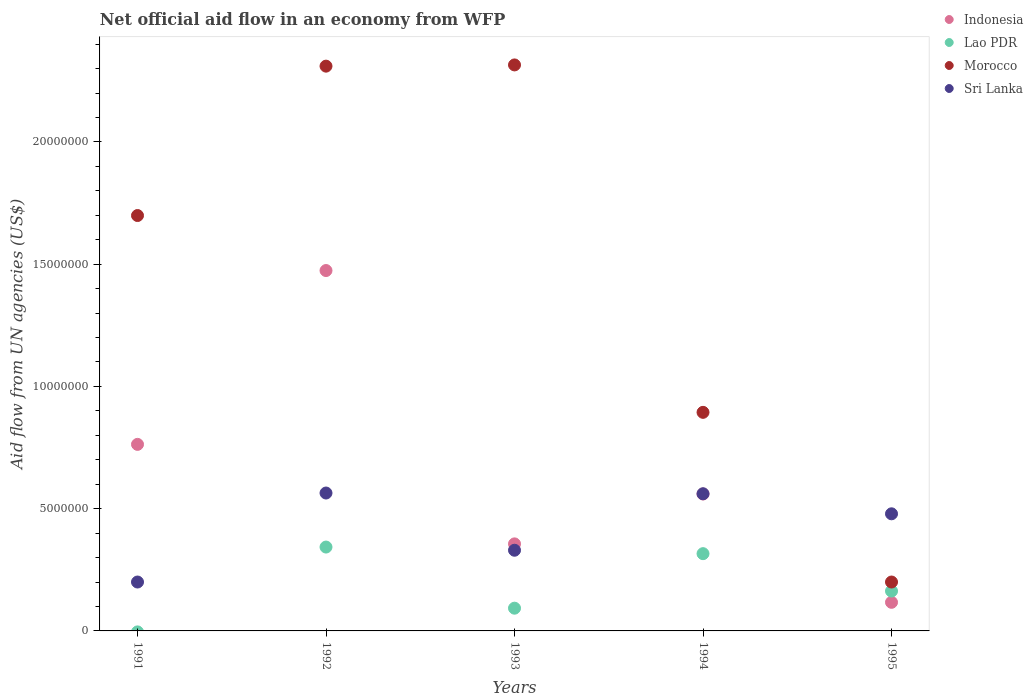Is the number of dotlines equal to the number of legend labels?
Offer a terse response. No. What is the net official aid flow in Lao PDR in 1992?
Ensure brevity in your answer.  3.43e+06. Across all years, what is the maximum net official aid flow in Morocco?
Your answer should be very brief. 2.32e+07. Across all years, what is the minimum net official aid flow in Indonesia?
Your answer should be compact. 1.17e+06. In which year was the net official aid flow in Morocco maximum?
Give a very brief answer. 1993. What is the total net official aid flow in Lao PDR in the graph?
Your answer should be very brief. 9.15e+06. What is the difference between the net official aid flow in Indonesia in 1994 and that in 1995?
Your answer should be compact. 4.43e+06. What is the difference between the net official aid flow in Morocco in 1991 and the net official aid flow in Lao PDR in 1992?
Ensure brevity in your answer.  1.36e+07. What is the average net official aid flow in Morocco per year?
Your answer should be very brief. 1.48e+07. In the year 1993, what is the difference between the net official aid flow in Morocco and net official aid flow in Lao PDR?
Keep it short and to the point. 2.22e+07. In how many years, is the net official aid flow in Lao PDR greater than 7000000 US$?
Provide a succinct answer. 0. What is the ratio of the net official aid flow in Morocco in 1991 to that in 1994?
Ensure brevity in your answer.  1.9. Is the difference between the net official aid flow in Morocco in 1992 and 1994 greater than the difference between the net official aid flow in Lao PDR in 1992 and 1994?
Your response must be concise. Yes. What is the difference between the highest and the lowest net official aid flow in Lao PDR?
Your response must be concise. 3.43e+06. Is the sum of the net official aid flow in Morocco in 1994 and 1995 greater than the maximum net official aid flow in Sri Lanka across all years?
Offer a terse response. Yes. Is it the case that in every year, the sum of the net official aid flow in Sri Lanka and net official aid flow in Morocco  is greater than the sum of net official aid flow in Lao PDR and net official aid flow in Indonesia?
Provide a succinct answer. Yes. Does the net official aid flow in Sri Lanka monotonically increase over the years?
Your answer should be compact. No. Is the net official aid flow in Morocco strictly less than the net official aid flow in Indonesia over the years?
Provide a succinct answer. No. What is the difference between two consecutive major ticks on the Y-axis?
Provide a short and direct response. 5.00e+06. Does the graph contain grids?
Your response must be concise. No. Where does the legend appear in the graph?
Give a very brief answer. Top right. What is the title of the graph?
Your response must be concise. Net official aid flow in an economy from WFP. What is the label or title of the X-axis?
Provide a short and direct response. Years. What is the label or title of the Y-axis?
Keep it short and to the point. Aid flow from UN agencies (US$). What is the Aid flow from UN agencies (US$) of Indonesia in 1991?
Provide a succinct answer. 7.63e+06. What is the Aid flow from UN agencies (US$) in Lao PDR in 1991?
Provide a short and direct response. 0. What is the Aid flow from UN agencies (US$) in Morocco in 1991?
Give a very brief answer. 1.70e+07. What is the Aid flow from UN agencies (US$) in Sri Lanka in 1991?
Offer a very short reply. 2.00e+06. What is the Aid flow from UN agencies (US$) in Indonesia in 1992?
Your response must be concise. 1.47e+07. What is the Aid flow from UN agencies (US$) of Lao PDR in 1992?
Your answer should be very brief. 3.43e+06. What is the Aid flow from UN agencies (US$) of Morocco in 1992?
Your answer should be very brief. 2.31e+07. What is the Aid flow from UN agencies (US$) of Sri Lanka in 1992?
Offer a very short reply. 5.64e+06. What is the Aid flow from UN agencies (US$) of Indonesia in 1993?
Ensure brevity in your answer.  3.56e+06. What is the Aid flow from UN agencies (US$) of Lao PDR in 1993?
Provide a short and direct response. 9.30e+05. What is the Aid flow from UN agencies (US$) in Morocco in 1993?
Give a very brief answer. 2.32e+07. What is the Aid flow from UN agencies (US$) of Sri Lanka in 1993?
Provide a short and direct response. 3.30e+06. What is the Aid flow from UN agencies (US$) of Indonesia in 1994?
Make the answer very short. 5.60e+06. What is the Aid flow from UN agencies (US$) in Lao PDR in 1994?
Provide a succinct answer. 3.16e+06. What is the Aid flow from UN agencies (US$) of Morocco in 1994?
Keep it short and to the point. 8.94e+06. What is the Aid flow from UN agencies (US$) of Sri Lanka in 1994?
Provide a succinct answer. 5.61e+06. What is the Aid flow from UN agencies (US$) of Indonesia in 1995?
Your answer should be compact. 1.17e+06. What is the Aid flow from UN agencies (US$) in Lao PDR in 1995?
Ensure brevity in your answer.  1.63e+06. What is the Aid flow from UN agencies (US$) of Sri Lanka in 1995?
Keep it short and to the point. 4.79e+06. Across all years, what is the maximum Aid flow from UN agencies (US$) in Indonesia?
Offer a terse response. 1.47e+07. Across all years, what is the maximum Aid flow from UN agencies (US$) of Lao PDR?
Keep it short and to the point. 3.43e+06. Across all years, what is the maximum Aid flow from UN agencies (US$) of Morocco?
Your answer should be very brief. 2.32e+07. Across all years, what is the maximum Aid flow from UN agencies (US$) in Sri Lanka?
Ensure brevity in your answer.  5.64e+06. Across all years, what is the minimum Aid flow from UN agencies (US$) of Indonesia?
Your response must be concise. 1.17e+06. What is the total Aid flow from UN agencies (US$) in Indonesia in the graph?
Offer a very short reply. 3.27e+07. What is the total Aid flow from UN agencies (US$) in Lao PDR in the graph?
Provide a succinct answer. 9.15e+06. What is the total Aid flow from UN agencies (US$) of Morocco in the graph?
Your answer should be compact. 7.42e+07. What is the total Aid flow from UN agencies (US$) of Sri Lanka in the graph?
Provide a short and direct response. 2.13e+07. What is the difference between the Aid flow from UN agencies (US$) of Indonesia in 1991 and that in 1992?
Give a very brief answer. -7.11e+06. What is the difference between the Aid flow from UN agencies (US$) of Morocco in 1991 and that in 1992?
Ensure brevity in your answer.  -6.11e+06. What is the difference between the Aid flow from UN agencies (US$) in Sri Lanka in 1991 and that in 1992?
Keep it short and to the point. -3.64e+06. What is the difference between the Aid flow from UN agencies (US$) of Indonesia in 1991 and that in 1993?
Keep it short and to the point. 4.07e+06. What is the difference between the Aid flow from UN agencies (US$) of Morocco in 1991 and that in 1993?
Your answer should be compact. -6.16e+06. What is the difference between the Aid flow from UN agencies (US$) in Sri Lanka in 1991 and that in 1993?
Offer a terse response. -1.30e+06. What is the difference between the Aid flow from UN agencies (US$) in Indonesia in 1991 and that in 1994?
Your response must be concise. 2.03e+06. What is the difference between the Aid flow from UN agencies (US$) in Morocco in 1991 and that in 1994?
Provide a short and direct response. 8.05e+06. What is the difference between the Aid flow from UN agencies (US$) of Sri Lanka in 1991 and that in 1994?
Provide a short and direct response. -3.61e+06. What is the difference between the Aid flow from UN agencies (US$) in Indonesia in 1991 and that in 1995?
Your answer should be compact. 6.46e+06. What is the difference between the Aid flow from UN agencies (US$) in Morocco in 1991 and that in 1995?
Offer a very short reply. 1.50e+07. What is the difference between the Aid flow from UN agencies (US$) of Sri Lanka in 1991 and that in 1995?
Your response must be concise. -2.79e+06. What is the difference between the Aid flow from UN agencies (US$) in Indonesia in 1992 and that in 1993?
Your answer should be compact. 1.12e+07. What is the difference between the Aid flow from UN agencies (US$) of Lao PDR in 1992 and that in 1993?
Keep it short and to the point. 2.50e+06. What is the difference between the Aid flow from UN agencies (US$) of Sri Lanka in 1992 and that in 1993?
Give a very brief answer. 2.34e+06. What is the difference between the Aid flow from UN agencies (US$) of Indonesia in 1992 and that in 1994?
Your answer should be very brief. 9.14e+06. What is the difference between the Aid flow from UN agencies (US$) in Morocco in 1992 and that in 1994?
Your answer should be compact. 1.42e+07. What is the difference between the Aid flow from UN agencies (US$) in Indonesia in 1992 and that in 1995?
Provide a succinct answer. 1.36e+07. What is the difference between the Aid flow from UN agencies (US$) of Lao PDR in 1992 and that in 1995?
Offer a very short reply. 1.80e+06. What is the difference between the Aid flow from UN agencies (US$) in Morocco in 1992 and that in 1995?
Give a very brief answer. 2.11e+07. What is the difference between the Aid flow from UN agencies (US$) of Sri Lanka in 1992 and that in 1995?
Offer a very short reply. 8.50e+05. What is the difference between the Aid flow from UN agencies (US$) in Indonesia in 1993 and that in 1994?
Provide a succinct answer. -2.04e+06. What is the difference between the Aid flow from UN agencies (US$) of Lao PDR in 1993 and that in 1994?
Offer a very short reply. -2.23e+06. What is the difference between the Aid flow from UN agencies (US$) of Morocco in 1993 and that in 1994?
Make the answer very short. 1.42e+07. What is the difference between the Aid flow from UN agencies (US$) of Sri Lanka in 1993 and that in 1994?
Your answer should be very brief. -2.31e+06. What is the difference between the Aid flow from UN agencies (US$) of Indonesia in 1993 and that in 1995?
Your answer should be compact. 2.39e+06. What is the difference between the Aid flow from UN agencies (US$) of Lao PDR in 1993 and that in 1995?
Offer a terse response. -7.00e+05. What is the difference between the Aid flow from UN agencies (US$) in Morocco in 1993 and that in 1995?
Provide a short and direct response. 2.12e+07. What is the difference between the Aid flow from UN agencies (US$) of Sri Lanka in 1993 and that in 1995?
Keep it short and to the point. -1.49e+06. What is the difference between the Aid flow from UN agencies (US$) of Indonesia in 1994 and that in 1995?
Your answer should be compact. 4.43e+06. What is the difference between the Aid flow from UN agencies (US$) of Lao PDR in 1994 and that in 1995?
Offer a very short reply. 1.53e+06. What is the difference between the Aid flow from UN agencies (US$) of Morocco in 1994 and that in 1995?
Your response must be concise. 6.94e+06. What is the difference between the Aid flow from UN agencies (US$) in Sri Lanka in 1994 and that in 1995?
Offer a terse response. 8.20e+05. What is the difference between the Aid flow from UN agencies (US$) in Indonesia in 1991 and the Aid flow from UN agencies (US$) in Lao PDR in 1992?
Your response must be concise. 4.20e+06. What is the difference between the Aid flow from UN agencies (US$) in Indonesia in 1991 and the Aid flow from UN agencies (US$) in Morocco in 1992?
Give a very brief answer. -1.55e+07. What is the difference between the Aid flow from UN agencies (US$) of Indonesia in 1991 and the Aid flow from UN agencies (US$) of Sri Lanka in 1992?
Ensure brevity in your answer.  1.99e+06. What is the difference between the Aid flow from UN agencies (US$) in Morocco in 1991 and the Aid flow from UN agencies (US$) in Sri Lanka in 1992?
Provide a succinct answer. 1.14e+07. What is the difference between the Aid flow from UN agencies (US$) in Indonesia in 1991 and the Aid flow from UN agencies (US$) in Lao PDR in 1993?
Your answer should be very brief. 6.70e+06. What is the difference between the Aid flow from UN agencies (US$) of Indonesia in 1991 and the Aid flow from UN agencies (US$) of Morocco in 1993?
Keep it short and to the point. -1.55e+07. What is the difference between the Aid flow from UN agencies (US$) in Indonesia in 1991 and the Aid flow from UN agencies (US$) in Sri Lanka in 1993?
Provide a short and direct response. 4.33e+06. What is the difference between the Aid flow from UN agencies (US$) in Morocco in 1991 and the Aid flow from UN agencies (US$) in Sri Lanka in 1993?
Make the answer very short. 1.37e+07. What is the difference between the Aid flow from UN agencies (US$) of Indonesia in 1991 and the Aid flow from UN agencies (US$) of Lao PDR in 1994?
Provide a short and direct response. 4.47e+06. What is the difference between the Aid flow from UN agencies (US$) of Indonesia in 1991 and the Aid flow from UN agencies (US$) of Morocco in 1994?
Make the answer very short. -1.31e+06. What is the difference between the Aid flow from UN agencies (US$) of Indonesia in 1991 and the Aid flow from UN agencies (US$) of Sri Lanka in 1994?
Give a very brief answer. 2.02e+06. What is the difference between the Aid flow from UN agencies (US$) in Morocco in 1991 and the Aid flow from UN agencies (US$) in Sri Lanka in 1994?
Offer a very short reply. 1.14e+07. What is the difference between the Aid flow from UN agencies (US$) of Indonesia in 1991 and the Aid flow from UN agencies (US$) of Morocco in 1995?
Keep it short and to the point. 5.63e+06. What is the difference between the Aid flow from UN agencies (US$) of Indonesia in 1991 and the Aid flow from UN agencies (US$) of Sri Lanka in 1995?
Ensure brevity in your answer.  2.84e+06. What is the difference between the Aid flow from UN agencies (US$) of Morocco in 1991 and the Aid flow from UN agencies (US$) of Sri Lanka in 1995?
Provide a succinct answer. 1.22e+07. What is the difference between the Aid flow from UN agencies (US$) of Indonesia in 1992 and the Aid flow from UN agencies (US$) of Lao PDR in 1993?
Provide a short and direct response. 1.38e+07. What is the difference between the Aid flow from UN agencies (US$) of Indonesia in 1992 and the Aid flow from UN agencies (US$) of Morocco in 1993?
Your response must be concise. -8.41e+06. What is the difference between the Aid flow from UN agencies (US$) of Indonesia in 1992 and the Aid flow from UN agencies (US$) of Sri Lanka in 1993?
Keep it short and to the point. 1.14e+07. What is the difference between the Aid flow from UN agencies (US$) in Lao PDR in 1992 and the Aid flow from UN agencies (US$) in Morocco in 1993?
Provide a succinct answer. -1.97e+07. What is the difference between the Aid flow from UN agencies (US$) in Morocco in 1992 and the Aid flow from UN agencies (US$) in Sri Lanka in 1993?
Ensure brevity in your answer.  1.98e+07. What is the difference between the Aid flow from UN agencies (US$) of Indonesia in 1992 and the Aid flow from UN agencies (US$) of Lao PDR in 1994?
Your response must be concise. 1.16e+07. What is the difference between the Aid flow from UN agencies (US$) of Indonesia in 1992 and the Aid flow from UN agencies (US$) of Morocco in 1994?
Your response must be concise. 5.80e+06. What is the difference between the Aid flow from UN agencies (US$) in Indonesia in 1992 and the Aid flow from UN agencies (US$) in Sri Lanka in 1994?
Provide a succinct answer. 9.13e+06. What is the difference between the Aid flow from UN agencies (US$) in Lao PDR in 1992 and the Aid flow from UN agencies (US$) in Morocco in 1994?
Provide a short and direct response. -5.51e+06. What is the difference between the Aid flow from UN agencies (US$) of Lao PDR in 1992 and the Aid flow from UN agencies (US$) of Sri Lanka in 1994?
Your answer should be very brief. -2.18e+06. What is the difference between the Aid flow from UN agencies (US$) in Morocco in 1992 and the Aid flow from UN agencies (US$) in Sri Lanka in 1994?
Offer a terse response. 1.75e+07. What is the difference between the Aid flow from UN agencies (US$) in Indonesia in 1992 and the Aid flow from UN agencies (US$) in Lao PDR in 1995?
Your response must be concise. 1.31e+07. What is the difference between the Aid flow from UN agencies (US$) in Indonesia in 1992 and the Aid flow from UN agencies (US$) in Morocco in 1995?
Offer a very short reply. 1.27e+07. What is the difference between the Aid flow from UN agencies (US$) in Indonesia in 1992 and the Aid flow from UN agencies (US$) in Sri Lanka in 1995?
Give a very brief answer. 9.95e+06. What is the difference between the Aid flow from UN agencies (US$) of Lao PDR in 1992 and the Aid flow from UN agencies (US$) of Morocco in 1995?
Your answer should be compact. 1.43e+06. What is the difference between the Aid flow from UN agencies (US$) of Lao PDR in 1992 and the Aid flow from UN agencies (US$) of Sri Lanka in 1995?
Provide a succinct answer. -1.36e+06. What is the difference between the Aid flow from UN agencies (US$) in Morocco in 1992 and the Aid flow from UN agencies (US$) in Sri Lanka in 1995?
Keep it short and to the point. 1.83e+07. What is the difference between the Aid flow from UN agencies (US$) of Indonesia in 1993 and the Aid flow from UN agencies (US$) of Lao PDR in 1994?
Your answer should be compact. 4.00e+05. What is the difference between the Aid flow from UN agencies (US$) of Indonesia in 1993 and the Aid flow from UN agencies (US$) of Morocco in 1994?
Your response must be concise. -5.38e+06. What is the difference between the Aid flow from UN agencies (US$) in Indonesia in 1993 and the Aid flow from UN agencies (US$) in Sri Lanka in 1994?
Make the answer very short. -2.05e+06. What is the difference between the Aid flow from UN agencies (US$) of Lao PDR in 1993 and the Aid flow from UN agencies (US$) of Morocco in 1994?
Ensure brevity in your answer.  -8.01e+06. What is the difference between the Aid flow from UN agencies (US$) of Lao PDR in 1993 and the Aid flow from UN agencies (US$) of Sri Lanka in 1994?
Provide a succinct answer. -4.68e+06. What is the difference between the Aid flow from UN agencies (US$) in Morocco in 1993 and the Aid flow from UN agencies (US$) in Sri Lanka in 1994?
Give a very brief answer. 1.75e+07. What is the difference between the Aid flow from UN agencies (US$) in Indonesia in 1993 and the Aid flow from UN agencies (US$) in Lao PDR in 1995?
Your response must be concise. 1.93e+06. What is the difference between the Aid flow from UN agencies (US$) of Indonesia in 1993 and the Aid flow from UN agencies (US$) of Morocco in 1995?
Provide a succinct answer. 1.56e+06. What is the difference between the Aid flow from UN agencies (US$) in Indonesia in 1993 and the Aid flow from UN agencies (US$) in Sri Lanka in 1995?
Give a very brief answer. -1.23e+06. What is the difference between the Aid flow from UN agencies (US$) in Lao PDR in 1993 and the Aid flow from UN agencies (US$) in Morocco in 1995?
Offer a very short reply. -1.07e+06. What is the difference between the Aid flow from UN agencies (US$) in Lao PDR in 1993 and the Aid flow from UN agencies (US$) in Sri Lanka in 1995?
Provide a short and direct response. -3.86e+06. What is the difference between the Aid flow from UN agencies (US$) of Morocco in 1993 and the Aid flow from UN agencies (US$) of Sri Lanka in 1995?
Provide a short and direct response. 1.84e+07. What is the difference between the Aid flow from UN agencies (US$) of Indonesia in 1994 and the Aid flow from UN agencies (US$) of Lao PDR in 1995?
Offer a very short reply. 3.97e+06. What is the difference between the Aid flow from UN agencies (US$) of Indonesia in 1994 and the Aid flow from UN agencies (US$) of Morocco in 1995?
Your response must be concise. 3.60e+06. What is the difference between the Aid flow from UN agencies (US$) in Indonesia in 1994 and the Aid flow from UN agencies (US$) in Sri Lanka in 1995?
Make the answer very short. 8.10e+05. What is the difference between the Aid flow from UN agencies (US$) in Lao PDR in 1994 and the Aid flow from UN agencies (US$) in Morocco in 1995?
Ensure brevity in your answer.  1.16e+06. What is the difference between the Aid flow from UN agencies (US$) in Lao PDR in 1994 and the Aid flow from UN agencies (US$) in Sri Lanka in 1995?
Provide a short and direct response. -1.63e+06. What is the difference between the Aid flow from UN agencies (US$) in Morocco in 1994 and the Aid flow from UN agencies (US$) in Sri Lanka in 1995?
Your answer should be very brief. 4.15e+06. What is the average Aid flow from UN agencies (US$) in Indonesia per year?
Provide a short and direct response. 6.54e+06. What is the average Aid flow from UN agencies (US$) in Lao PDR per year?
Provide a succinct answer. 1.83e+06. What is the average Aid flow from UN agencies (US$) of Morocco per year?
Your answer should be very brief. 1.48e+07. What is the average Aid flow from UN agencies (US$) in Sri Lanka per year?
Offer a terse response. 4.27e+06. In the year 1991, what is the difference between the Aid flow from UN agencies (US$) in Indonesia and Aid flow from UN agencies (US$) in Morocco?
Provide a succinct answer. -9.36e+06. In the year 1991, what is the difference between the Aid flow from UN agencies (US$) in Indonesia and Aid flow from UN agencies (US$) in Sri Lanka?
Provide a short and direct response. 5.63e+06. In the year 1991, what is the difference between the Aid flow from UN agencies (US$) in Morocco and Aid flow from UN agencies (US$) in Sri Lanka?
Your answer should be compact. 1.50e+07. In the year 1992, what is the difference between the Aid flow from UN agencies (US$) of Indonesia and Aid flow from UN agencies (US$) of Lao PDR?
Keep it short and to the point. 1.13e+07. In the year 1992, what is the difference between the Aid flow from UN agencies (US$) of Indonesia and Aid flow from UN agencies (US$) of Morocco?
Your response must be concise. -8.36e+06. In the year 1992, what is the difference between the Aid flow from UN agencies (US$) of Indonesia and Aid flow from UN agencies (US$) of Sri Lanka?
Give a very brief answer. 9.10e+06. In the year 1992, what is the difference between the Aid flow from UN agencies (US$) of Lao PDR and Aid flow from UN agencies (US$) of Morocco?
Offer a very short reply. -1.97e+07. In the year 1992, what is the difference between the Aid flow from UN agencies (US$) of Lao PDR and Aid flow from UN agencies (US$) of Sri Lanka?
Make the answer very short. -2.21e+06. In the year 1992, what is the difference between the Aid flow from UN agencies (US$) in Morocco and Aid flow from UN agencies (US$) in Sri Lanka?
Give a very brief answer. 1.75e+07. In the year 1993, what is the difference between the Aid flow from UN agencies (US$) in Indonesia and Aid flow from UN agencies (US$) in Lao PDR?
Keep it short and to the point. 2.63e+06. In the year 1993, what is the difference between the Aid flow from UN agencies (US$) in Indonesia and Aid flow from UN agencies (US$) in Morocco?
Ensure brevity in your answer.  -1.96e+07. In the year 1993, what is the difference between the Aid flow from UN agencies (US$) in Indonesia and Aid flow from UN agencies (US$) in Sri Lanka?
Your answer should be very brief. 2.60e+05. In the year 1993, what is the difference between the Aid flow from UN agencies (US$) of Lao PDR and Aid flow from UN agencies (US$) of Morocco?
Offer a very short reply. -2.22e+07. In the year 1993, what is the difference between the Aid flow from UN agencies (US$) in Lao PDR and Aid flow from UN agencies (US$) in Sri Lanka?
Your answer should be compact. -2.37e+06. In the year 1993, what is the difference between the Aid flow from UN agencies (US$) in Morocco and Aid flow from UN agencies (US$) in Sri Lanka?
Offer a very short reply. 1.98e+07. In the year 1994, what is the difference between the Aid flow from UN agencies (US$) of Indonesia and Aid flow from UN agencies (US$) of Lao PDR?
Keep it short and to the point. 2.44e+06. In the year 1994, what is the difference between the Aid flow from UN agencies (US$) in Indonesia and Aid flow from UN agencies (US$) in Morocco?
Provide a short and direct response. -3.34e+06. In the year 1994, what is the difference between the Aid flow from UN agencies (US$) in Lao PDR and Aid flow from UN agencies (US$) in Morocco?
Your answer should be compact. -5.78e+06. In the year 1994, what is the difference between the Aid flow from UN agencies (US$) in Lao PDR and Aid flow from UN agencies (US$) in Sri Lanka?
Make the answer very short. -2.45e+06. In the year 1994, what is the difference between the Aid flow from UN agencies (US$) of Morocco and Aid flow from UN agencies (US$) of Sri Lanka?
Offer a very short reply. 3.33e+06. In the year 1995, what is the difference between the Aid flow from UN agencies (US$) of Indonesia and Aid flow from UN agencies (US$) of Lao PDR?
Keep it short and to the point. -4.60e+05. In the year 1995, what is the difference between the Aid flow from UN agencies (US$) in Indonesia and Aid flow from UN agencies (US$) in Morocco?
Make the answer very short. -8.30e+05. In the year 1995, what is the difference between the Aid flow from UN agencies (US$) in Indonesia and Aid flow from UN agencies (US$) in Sri Lanka?
Provide a short and direct response. -3.62e+06. In the year 1995, what is the difference between the Aid flow from UN agencies (US$) in Lao PDR and Aid flow from UN agencies (US$) in Morocco?
Your answer should be compact. -3.70e+05. In the year 1995, what is the difference between the Aid flow from UN agencies (US$) in Lao PDR and Aid flow from UN agencies (US$) in Sri Lanka?
Provide a short and direct response. -3.16e+06. In the year 1995, what is the difference between the Aid flow from UN agencies (US$) of Morocco and Aid flow from UN agencies (US$) of Sri Lanka?
Provide a succinct answer. -2.79e+06. What is the ratio of the Aid flow from UN agencies (US$) of Indonesia in 1991 to that in 1992?
Provide a succinct answer. 0.52. What is the ratio of the Aid flow from UN agencies (US$) in Morocco in 1991 to that in 1992?
Your answer should be very brief. 0.74. What is the ratio of the Aid flow from UN agencies (US$) in Sri Lanka in 1991 to that in 1992?
Your answer should be very brief. 0.35. What is the ratio of the Aid flow from UN agencies (US$) in Indonesia in 1991 to that in 1993?
Offer a terse response. 2.14. What is the ratio of the Aid flow from UN agencies (US$) of Morocco in 1991 to that in 1993?
Offer a terse response. 0.73. What is the ratio of the Aid flow from UN agencies (US$) in Sri Lanka in 1991 to that in 1993?
Your answer should be compact. 0.61. What is the ratio of the Aid flow from UN agencies (US$) of Indonesia in 1991 to that in 1994?
Your response must be concise. 1.36. What is the ratio of the Aid flow from UN agencies (US$) in Morocco in 1991 to that in 1994?
Provide a succinct answer. 1.9. What is the ratio of the Aid flow from UN agencies (US$) in Sri Lanka in 1991 to that in 1994?
Offer a terse response. 0.36. What is the ratio of the Aid flow from UN agencies (US$) of Indonesia in 1991 to that in 1995?
Provide a succinct answer. 6.52. What is the ratio of the Aid flow from UN agencies (US$) in Morocco in 1991 to that in 1995?
Your response must be concise. 8.49. What is the ratio of the Aid flow from UN agencies (US$) of Sri Lanka in 1991 to that in 1995?
Provide a succinct answer. 0.42. What is the ratio of the Aid flow from UN agencies (US$) in Indonesia in 1992 to that in 1993?
Your answer should be very brief. 4.14. What is the ratio of the Aid flow from UN agencies (US$) of Lao PDR in 1992 to that in 1993?
Offer a terse response. 3.69. What is the ratio of the Aid flow from UN agencies (US$) in Sri Lanka in 1992 to that in 1993?
Provide a succinct answer. 1.71. What is the ratio of the Aid flow from UN agencies (US$) of Indonesia in 1992 to that in 1994?
Offer a terse response. 2.63. What is the ratio of the Aid flow from UN agencies (US$) of Lao PDR in 1992 to that in 1994?
Make the answer very short. 1.09. What is the ratio of the Aid flow from UN agencies (US$) in Morocco in 1992 to that in 1994?
Give a very brief answer. 2.58. What is the ratio of the Aid flow from UN agencies (US$) in Indonesia in 1992 to that in 1995?
Make the answer very short. 12.6. What is the ratio of the Aid flow from UN agencies (US$) in Lao PDR in 1992 to that in 1995?
Your response must be concise. 2.1. What is the ratio of the Aid flow from UN agencies (US$) of Morocco in 1992 to that in 1995?
Keep it short and to the point. 11.55. What is the ratio of the Aid flow from UN agencies (US$) in Sri Lanka in 1992 to that in 1995?
Ensure brevity in your answer.  1.18. What is the ratio of the Aid flow from UN agencies (US$) in Indonesia in 1993 to that in 1994?
Make the answer very short. 0.64. What is the ratio of the Aid flow from UN agencies (US$) of Lao PDR in 1993 to that in 1994?
Offer a very short reply. 0.29. What is the ratio of the Aid flow from UN agencies (US$) in Morocco in 1993 to that in 1994?
Your answer should be very brief. 2.59. What is the ratio of the Aid flow from UN agencies (US$) of Sri Lanka in 1993 to that in 1994?
Ensure brevity in your answer.  0.59. What is the ratio of the Aid flow from UN agencies (US$) in Indonesia in 1993 to that in 1995?
Offer a terse response. 3.04. What is the ratio of the Aid flow from UN agencies (US$) of Lao PDR in 1993 to that in 1995?
Provide a short and direct response. 0.57. What is the ratio of the Aid flow from UN agencies (US$) of Morocco in 1993 to that in 1995?
Give a very brief answer. 11.57. What is the ratio of the Aid flow from UN agencies (US$) of Sri Lanka in 1993 to that in 1995?
Your response must be concise. 0.69. What is the ratio of the Aid flow from UN agencies (US$) in Indonesia in 1994 to that in 1995?
Provide a short and direct response. 4.79. What is the ratio of the Aid flow from UN agencies (US$) in Lao PDR in 1994 to that in 1995?
Keep it short and to the point. 1.94. What is the ratio of the Aid flow from UN agencies (US$) in Morocco in 1994 to that in 1995?
Offer a very short reply. 4.47. What is the ratio of the Aid flow from UN agencies (US$) of Sri Lanka in 1994 to that in 1995?
Offer a terse response. 1.17. What is the difference between the highest and the second highest Aid flow from UN agencies (US$) of Indonesia?
Keep it short and to the point. 7.11e+06. What is the difference between the highest and the second highest Aid flow from UN agencies (US$) in Lao PDR?
Offer a terse response. 2.70e+05. What is the difference between the highest and the lowest Aid flow from UN agencies (US$) in Indonesia?
Your answer should be very brief. 1.36e+07. What is the difference between the highest and the lowest Aid flow from UN agencies (US$) in Lao PDR?
Offer a very short reply. 3.43e+06. What is the difference between the highest and the lowest Aid flow from UN agencies (US$) in Morocco?
Offer a terse response. 2.12e+07. What is the difference between the highest and the lowest Aid flow from UN agencies (US$) in Sri Lanka?
Make the answer very short. 3.64e+06. 